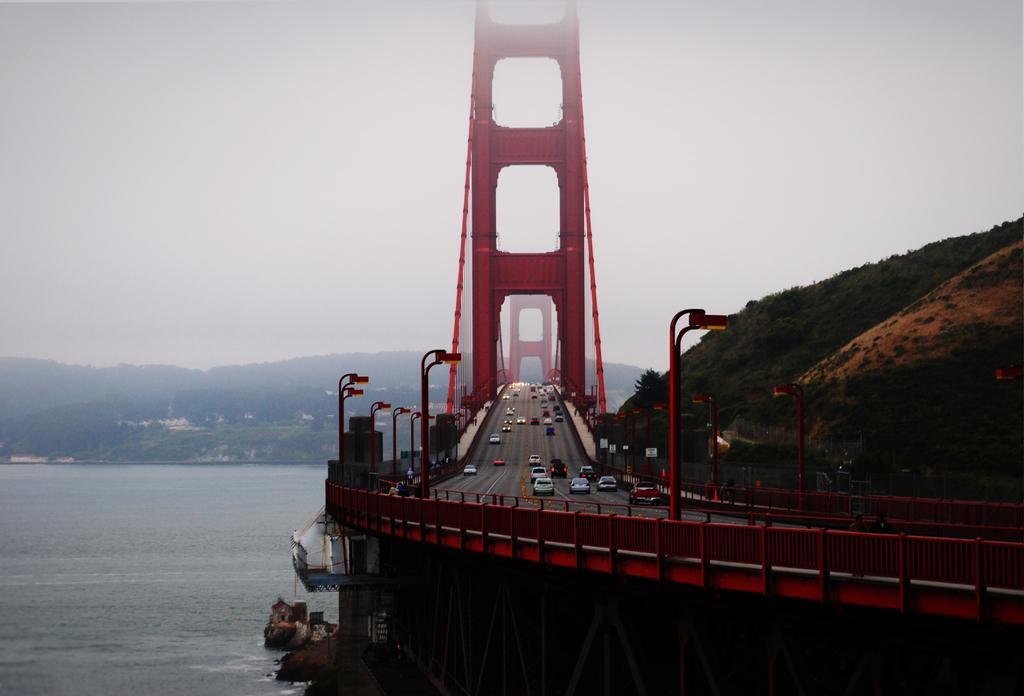In one or two sentences, can you explain what this image depicts? In this image we can see a bridge, on the bridge we can see a few vehicles, poles, lights, arches and boards, there are some trees, water and mountains, in the background we can see the sky. 